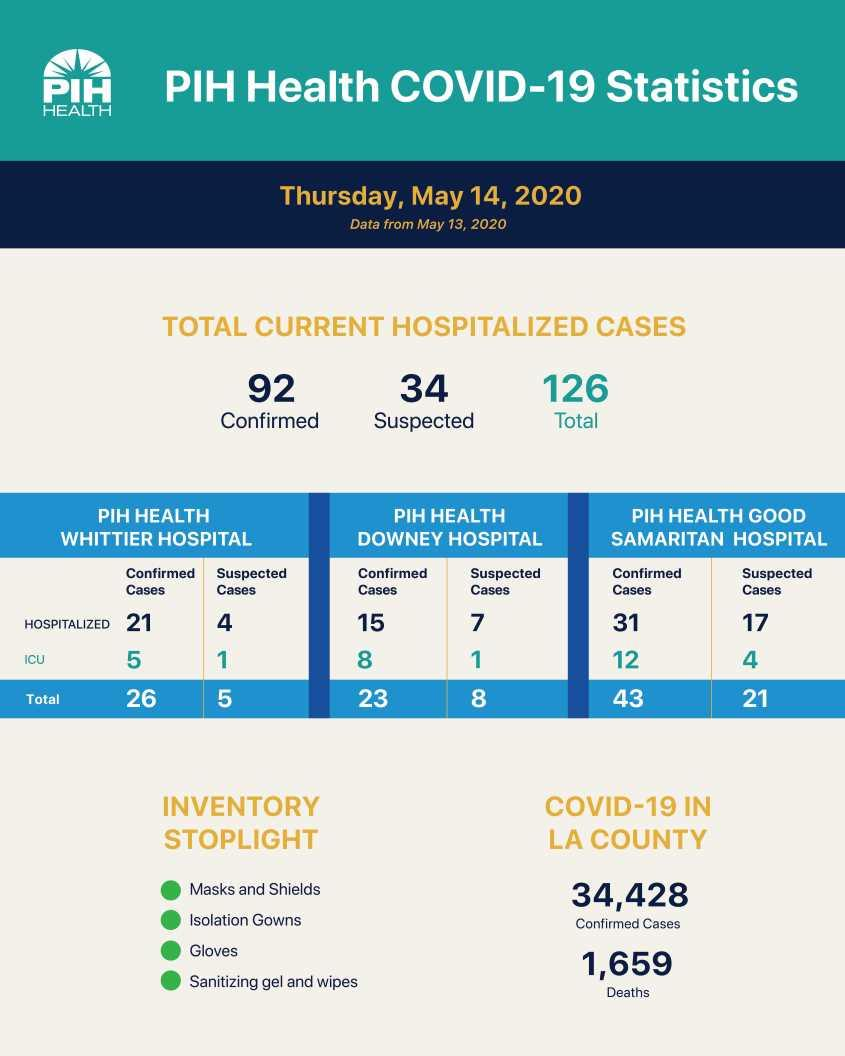Point out several critical features in this image. As of May 14, 2020, there were a total of 15 confirmed COVID-19 cases that were hospitalized at the PIH Health Downey hospital. As of May 14, 2020, a total of one suspected COVID-19 case was hospitalised in the ICU at PIH Health Downey hospital. As of May 14, 2020, a total of 4 suspected COVID-19 cases were hospitalised in the ICU at PIH Health Good Samaritan hospital. As of May 14, 2020, the total number of suspected COVID-19 cases reported at PIH Health Whittier hospital is 5. As of May 14, 2020, the total number of confirmed COVID-19 cases reported at PIH Health Downey Hospital is 23. 